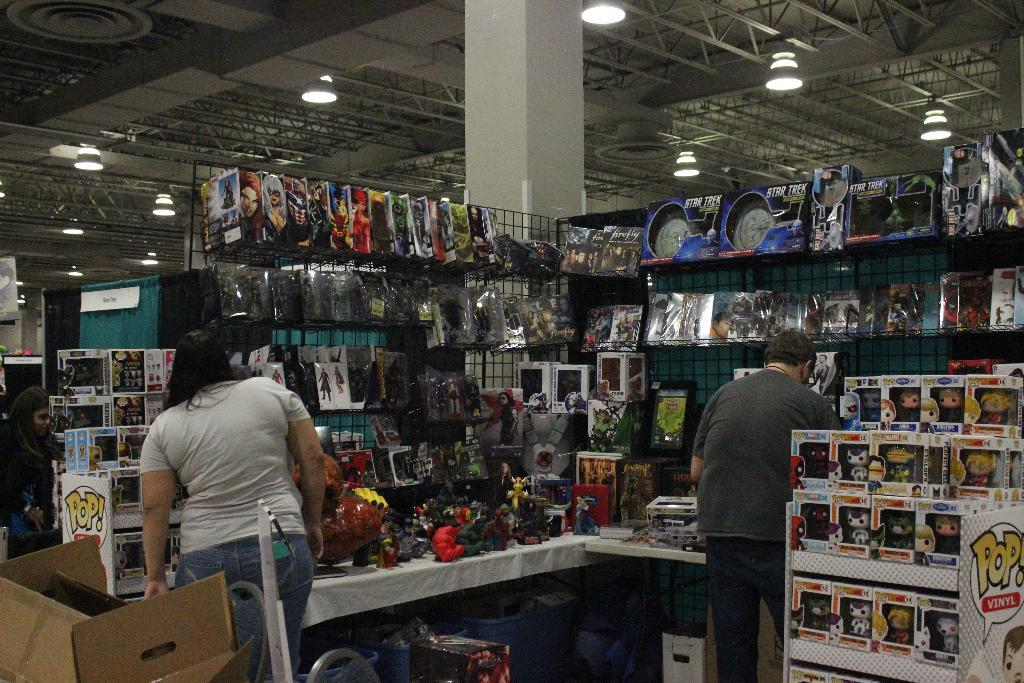<image>
Write a terse but informative summary of the picture. A selection of toys including Star Trek toys on the top shelf. 